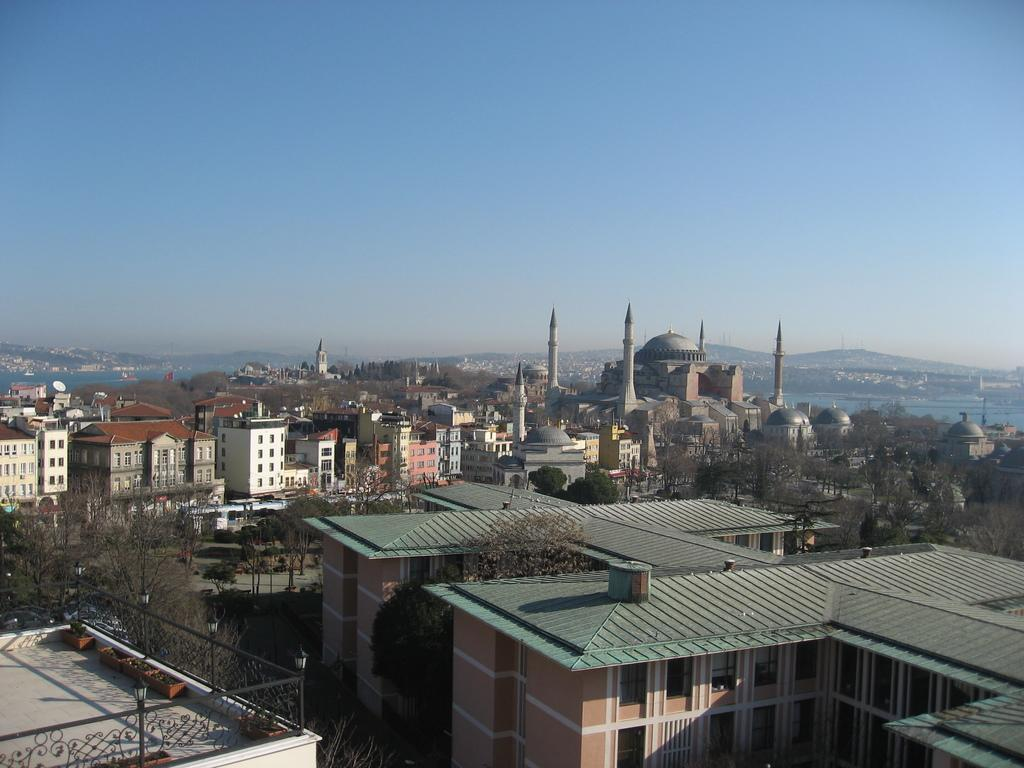What type of structures can be seen in the image? There are buildings in the image. What natural elements are present in the image? There are trees and water visible in the image. What geographical feature can be seen in the image? There are mountains in the image. What man-made object is present in the image? There is a fence in the image. What type of plants are in the image? There are potted plants in the image. What is visible in the background of the image? The sky is visible in the background of the image. What type of cork can be seen in the image? There is no cork present in the image. Is the calculator used to perform calculations in the image? There is no calculator present in the image. 